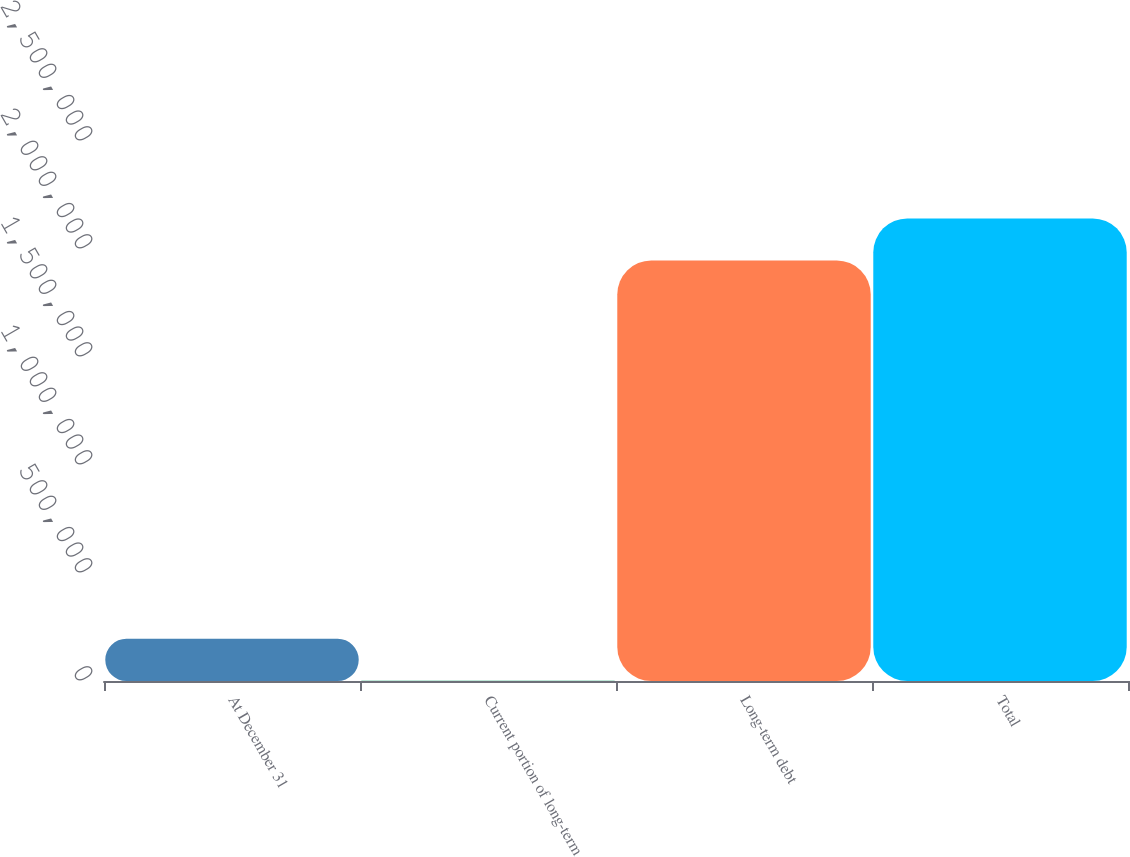Convert chart to OTSL. <chart><loc_0><loc_0><loc_500><loc_500><bar_chart><fcel>At December 31<fcel>Current portion of long-term<fcel>Long-term debt<fcel>Total<nl><fcel>195616<fcel>914<fcel>1.94702e+06<fcel>2.14173e+06<nl></chart> 